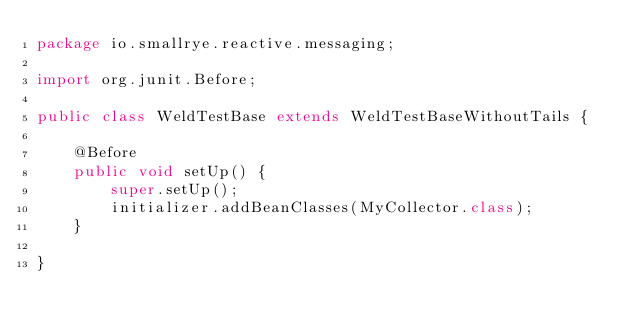<code> <loc_0><loc_0><loc_500><loc_500><_Java_>package io.smallrye.reactive.messaging;

import org.junit.Before;

public class WeldTestBase extends WeldTestBaseWithoutTails {

    @Before
    public void setUp() {
        super.setUp();
        initializer.addBeanClasses(MyCollector.class);
    }

}
</code> 